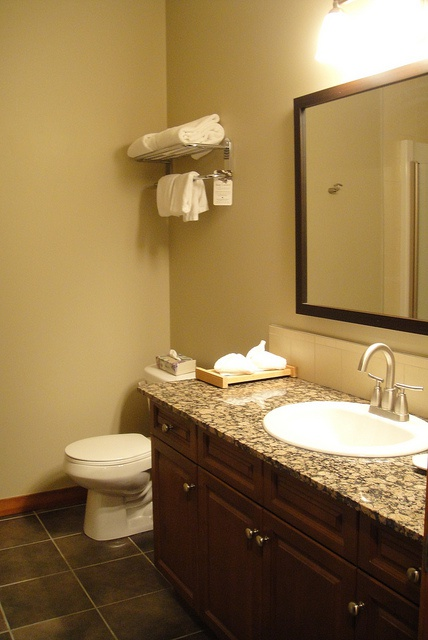Describe the objects in this image and their specific colors. I can see sink in olive, ivory, and tan tones and toilet in olive and tan tones in this image. 